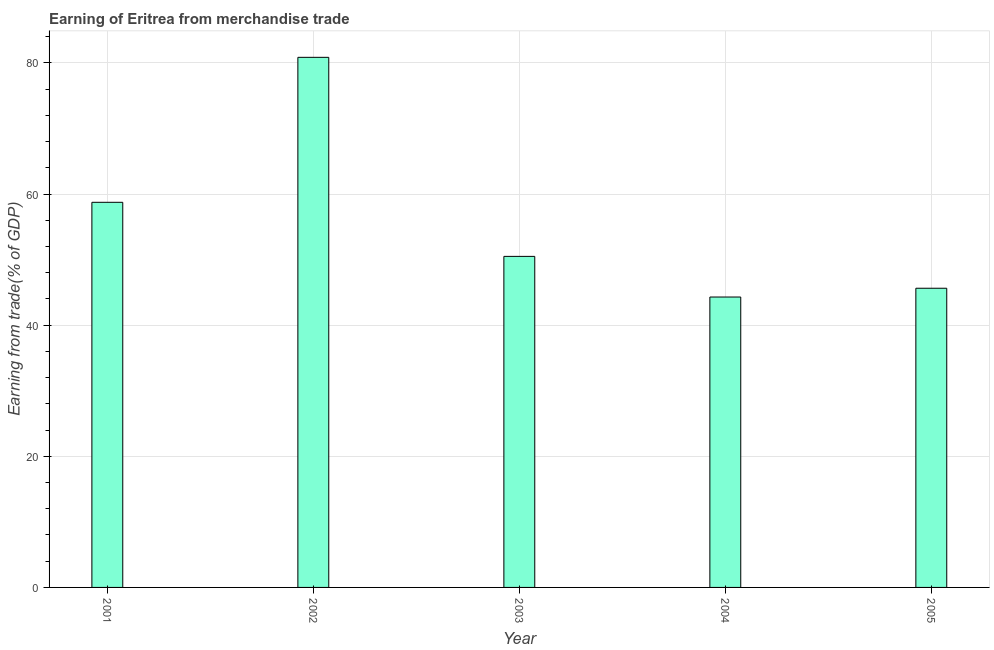Does the graph contain any zero values?
Give a very brief answer. No. Does the graph contain grids?
Give a very brief answer. Yes. What is the title of the graph?
Give a very brief answer. Earning of Eritrea from merchandise trade. What is the label or title of the X-axis?
Provide a short and direct response. Year. What is the label or title of the Y-axis?
Give a very brief answer. Earning from trade(% of GDP). What is the earning from merchandise trade in 2002?
Your answer should be compact. 80.86. Across all years, what is the maximum earning from merchandise trade?
Your response must be concise. 80.86. Across all years, what is the minimum earning from merchandise trade?
Provide a succinct answer. 44.3. In which year was the earning from merchandise trade minimum?
Your answer should be compact. 2004. What is the sum of the earning from merchandise trade?
Ensure brevity in your answer.  280.05. What is the difference between the earning from merchandise trade in 2002 and 2003?
Your answer should be very brief. 30.36. What is the average earning from merchandise trade per year?
Your response must be concise. 56.01. What is the median earning from merchandise trade?
Offer a terse response. 50.5. In how many years, is the earning from merchandise trade greater than 80 %?
Offer a terse response. 1. Do a majority of the years between 2001 and 2004 (inclusive) have earning from merchandise trade greater than 4 %?
Provide a succinct answer. Yes. What is the difference between the highest and the second highest earning from merchandise trade?
Ensure brevity in your answer.  22.11. What is the difference between the highest and the lowest earning from merchandise trade?
Give a very brief answer. 36.56. How many bars are there?
Your response must be concise. 5. Are all the bars in the graph horizontal?
Make the answer very short. No. How many years are there in the graph?
Offer a very short reply. 5. What is the difference between two consecutive major ticks on the Y-axis?
Provide a short and direct response. 20. Are the values on the major ticks of Y-axis written in scientific E-notation?
Offer a very short reply. No. What is the Earning from trade(% of GDP) in 2001?
Give a very brief answer. 58.75. What is the Earning from trade(% of GDP) in 2002?
Ensure brevity in your answer.  80.86. What is the Earning from trade(% of GDP) in 2003?
Keep it short and to the point. 50.5. What is the Earning from trade(% of GDP) of 2004?
Ensure brevity in your answer.  44.3. What is the Earning from trade(% of GDP) of 2005?
Offer a terse response. 45.64. What is the difference between the Earning from trade(% of GDP) in 2001 and 2002?
Provide a short and direct response. -22.12. What is the difference between the Earning from trade(% of GDP) in 2001 and 2003?
Keep it short and to the point. 8.25. What is the difference between the Earning from trade(% of GDP) in 2001 and 2004?
Provide a succinct answer. 14.45. What is the difference between the Earning from trade(% of GDP) in 2001 and 2005?
Your response must be concise. 13.11. What is the difference between the Earning from trade(% of GDP) in 2002 and 2003?
Provide a succinct answer. 30.37. What is the difference between the Earning from trade(% of GDP) in 2002 and 2004?
Offer a terse response. 36.56. What is the difference between the Earning from trade(% of GDP) in 2002 and 2005?
Your answer should be compact. 35.22. What is the difference between the Earning from trade(% of GDP) in 2003 and 2004?
Offer a terse response. 6.2. What is the difference between the Earning from trade(% of GDP) in 2003 and 2005?
Provide a succinct answer. 4.86. What is the difference between the Earning from trade(% of GDP) in 2004 and 2005?
Your answer should be very brief. -1.34. What is the ratio of the Earning from trade(% of GDP) in 2001 to that in 2002?
Your answer should be compact. 0.73. What is the ratio of the Earning from trade(% of GDP) in 2001 to that in 2003?
Ensure brevity in your answer.  1.16. What is the ratio of the Earning from trade(% of GDP) in 2001 to that in 2004?
Provide a succinct answer. 1.33. What is the ratio of the Earning from trade(% of GDP) in 2001 to that in 2005?
Your answer should be very brief. 1.29. What is the ratio of the Earning from trade(% of GDP) in 2002 to that in 2003?
Ensure brevity in your answer.  1.6. What is the ratio of the Earning from trade(% of GDP) in 2002 to that in 2004?
Provide a short and direct response. 1.82. What is the ratio of the Earning from trade(% of GDP) in 2002 to that in 2005?
Give a very brief answer. 1.77. What is the ratio of the Earning from trade(% of GDP) in 2003 to that in 2004?
Make the answer very short. 1.14. What is the ratio of the Earning from trade(% of GDP) in 2003 to that in 2005?
Provide a succinct answer. 1.11. What is the ratio of the Earning from trade(% of GDP) in 2004 to that in 2005?
Offer a very short reply. 0.97. 